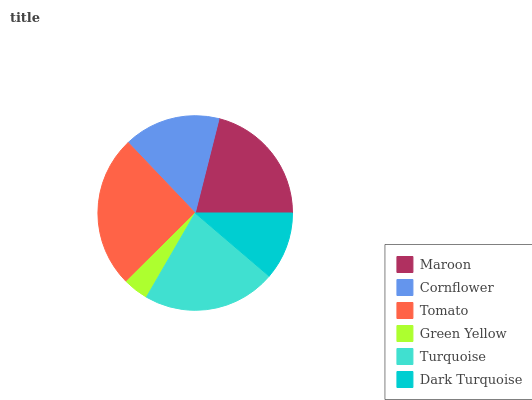Is Green Yellow the minimum?
Answer yes or no. Yes. Is Tomato the maximum?
Answer yes or no. Yes. Is Cornflower the minimum?
Answer yes or no. No. Is Cornflower the maximum?
Answer yes or no. No. Is Maroon greater than Cornflower?
Answer yes or no. Yes. Is Cornflower less than Maroon?
Answer yes or no. Yes. Is Cornflower greater than Maroon?
Answer yes or no. No. Is Maroon less than Cornflower?
Answer yes or no. No. Is Maroon the high median?
Answer yes or no. Yes. Is Cornflower the low median?
Answer yes or no. Yes. Is Tomato the high median?
Answer yes or no. No. Is Green Yellow the low median?
Answer yes or no. No. 